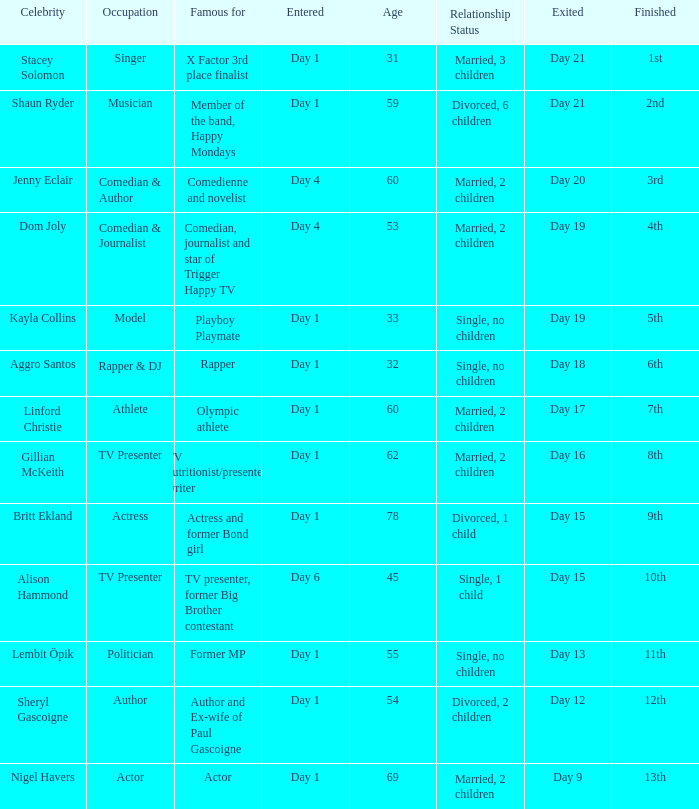What was Dom Joly famous for? Comedian, journalist and star of Trigger Happy TV. 